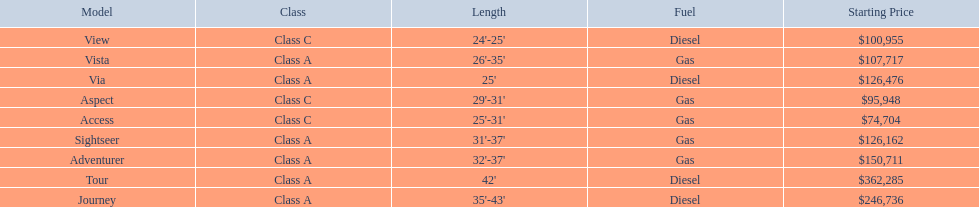Which of the models in the table use diesel fuel? Tour, Journey, Via, View. Of these models, which are class a? Tour, Journey, Via. Which of them are greater than 35' in length? Tour, Journey. Which of the two models is more expensive? Tour. 